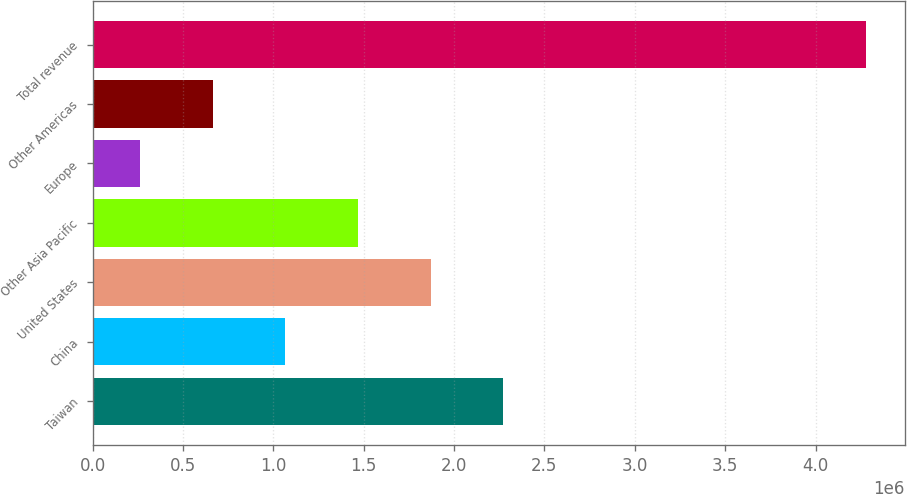Convert chart to OTSL. <chart><loc_0><loc_0><loc_500><loc_500><bar_chart><fcel>Taiwan<fcel>China<fcel>United States<fcel>Other Asia Pacific<fcel>Europe<fcel>Other Americas<fcel>Total revenue<nl><fcel>2.27182e+06<fcel>1.06682e+06<fcel>1.87016e+06<fcel>1.46849e+06<fcel>263488<fcel>665155<fcel>4.28016e+06<nl></chart> 